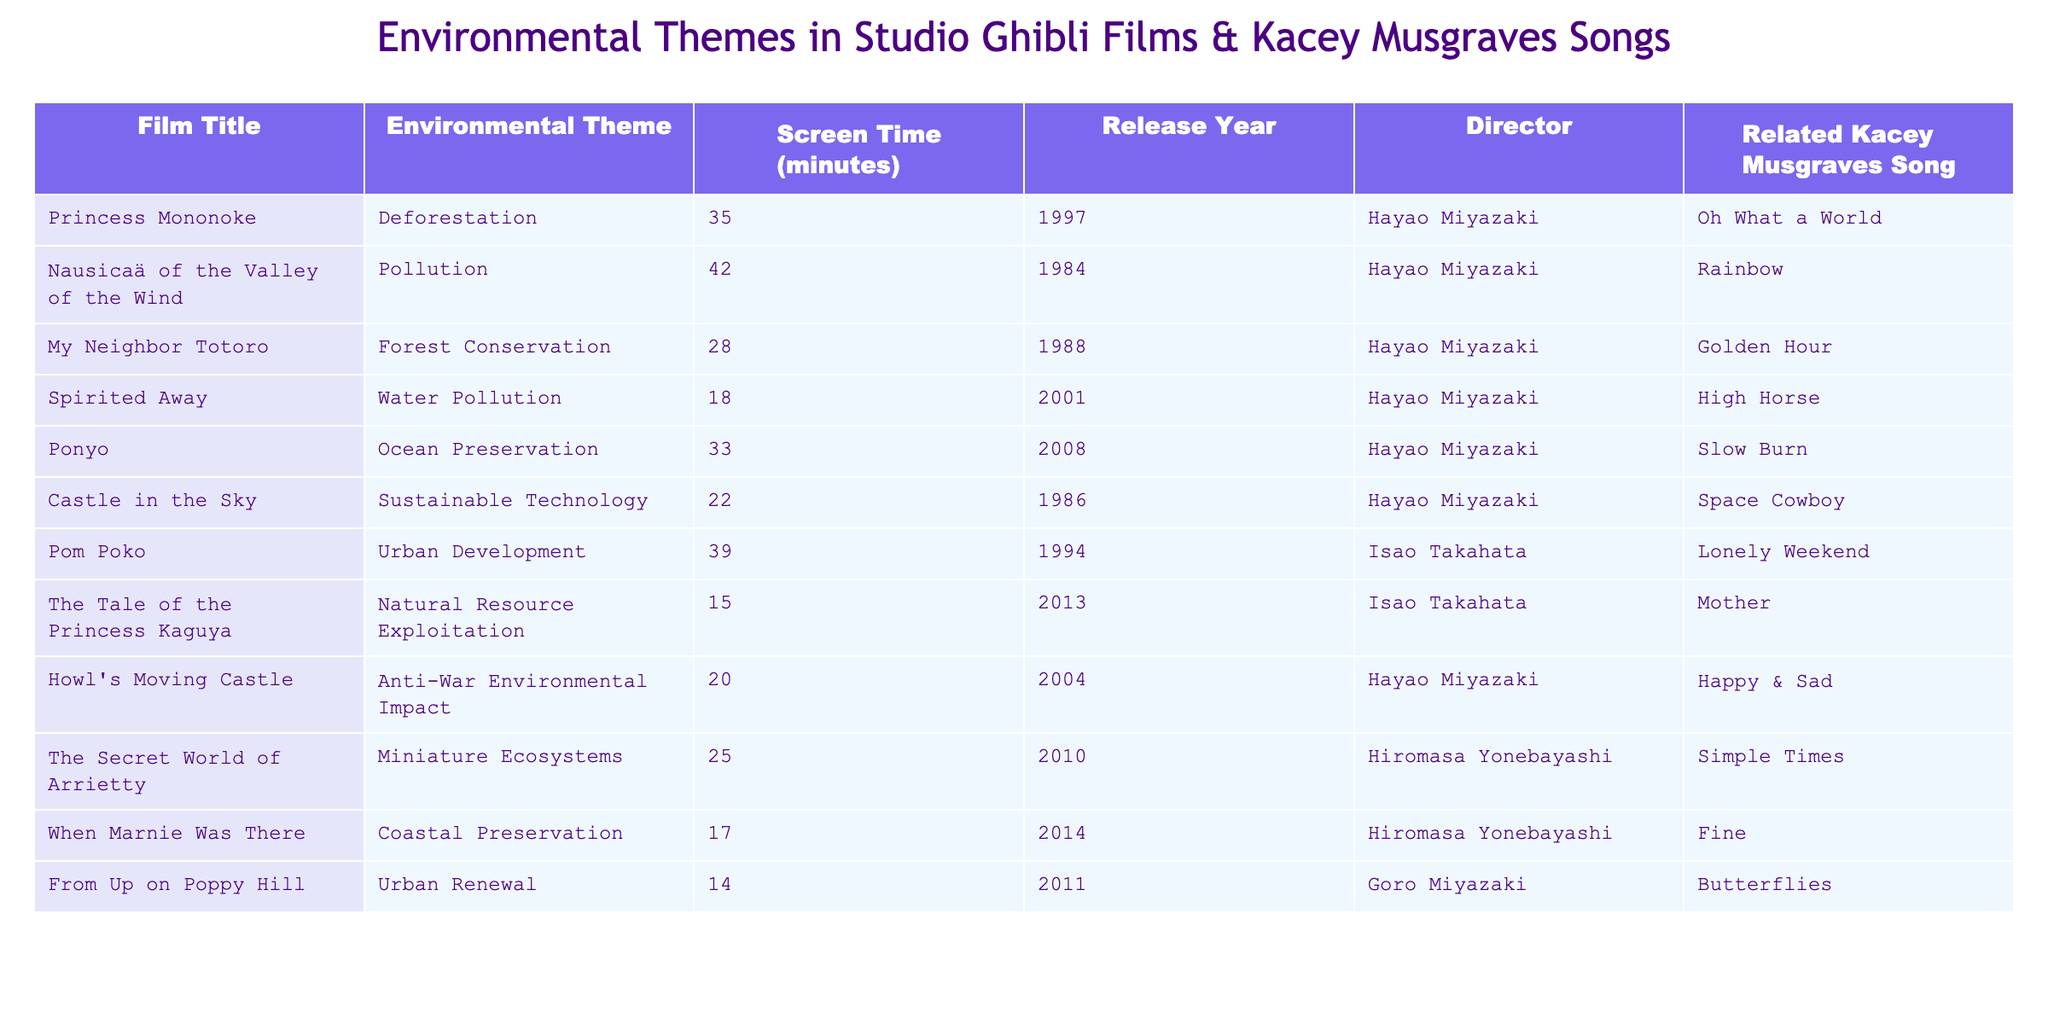What is the film with the longest screen time focused on pollution? The film "Nausicaä of the Valley of the Wind" has the longest screen time focused on pollution at 42 minutes. Looking at the environmental themes related to pollution, I see that it is the only film listed with this theme and its corresponding screen time.
Answer: Nausicaä of the Valley of the Wind Which environmental theme has the least screen time across the films? The environmental theme of "Natural Resource Exploitation" in "The Tale of the Princess Kaguya" has the least screen time at 15 minutes. By comparing the screen times of all themes, this is the smallest value noted.
Answer: Natural Resource Exploitation How many minutes are dedicated to urban development in total across the films? The films "Pom Poko" and "From Up on Poppy Hill" focus on urban development, with screen times of 39 and 14 minutes respectively. When added together, 39 + 14 equals 53 minutes in total for urban development.
Answer: 53 What is the average screen time for all the films listed in the table? To find the average screen time, first, I sum all the individual screen times: 35 + 42 + 28 + 18 + 33 + 22 + 39 + 15 + 20 + 25 + 17 + 14 =  387 minutes. There are 12 films, so I divide this total by 12, resulting in an average of 32.25 minutes.
Answer: 32.25 Is there a film with the environmental theme of ocean preservation that has the highest screen time? Yes, the film "Ponyo," which focuses on ocean preservation, has a screen time of 33 minutes. It is the only film with this environmental theme, thus making it the highest screen time for this category.
Answer: Yes Which film directed by Isao Takahata has a longer screen time than "Spirited Away"? "Pom Poko," directed by Isao Takahata, has a screen time of 39 minutes, which is longer than "Spirited Away," which has 18 minutes. Therefore, I can confirm that "Pom Poko" surpasses it.
Answer: Pom Poko How many films released before 2000 have an environmental theme of deforestation, pollution, or urban development? The films "Nausicaä of the Valley of the Wind" (pollution), "Princess Mononoke" (deforestation), and "Pom Poko" (urban development) all released before 2000. Counting these, there are three films with those themes.
Answer: 3 Which director has the most films listed in this table? Hayao Miyazaki directed "Princess Mononoke," "Nausicaä of the Valley of the Wind," "My Neighbor Totoro," "Spirited Away," "Ponyo," "Castle in the Sky," and "Howl's Moving Castle," totaling 7 films. Thus, he is the director with the most films represented in the table.
Answer: Hayao Miyazaki Do any films have the same environmental theme as Kacey Musgraves’ song “Golden Hour”? Yes, "My Neighbor Totoro," which relates to forest conservation, shares the same environmental theme reflected in Kacey Musgraves' song "Golden Hour." Both highlight the beauty of nature and its preservation.
Answer: Yes 